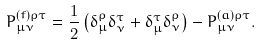Convert formula to latex. <formula><loc_0><loc_0><loc_500><loc_500>P ^ { ( f ) \rho \tau } _ { \mu \nu } = \frac { 1 } { 2 } \left ( \delta _ { \mu } ^ { \rho } \delta _ { \nu } ^ { \tau } + \delta _ { \mu } ^ { \tau } \delta _ { \nu } ^ { \rho } \right ) - P ^ { ( a ) \rho \tau } _ { \mu \nu } .</formula> 